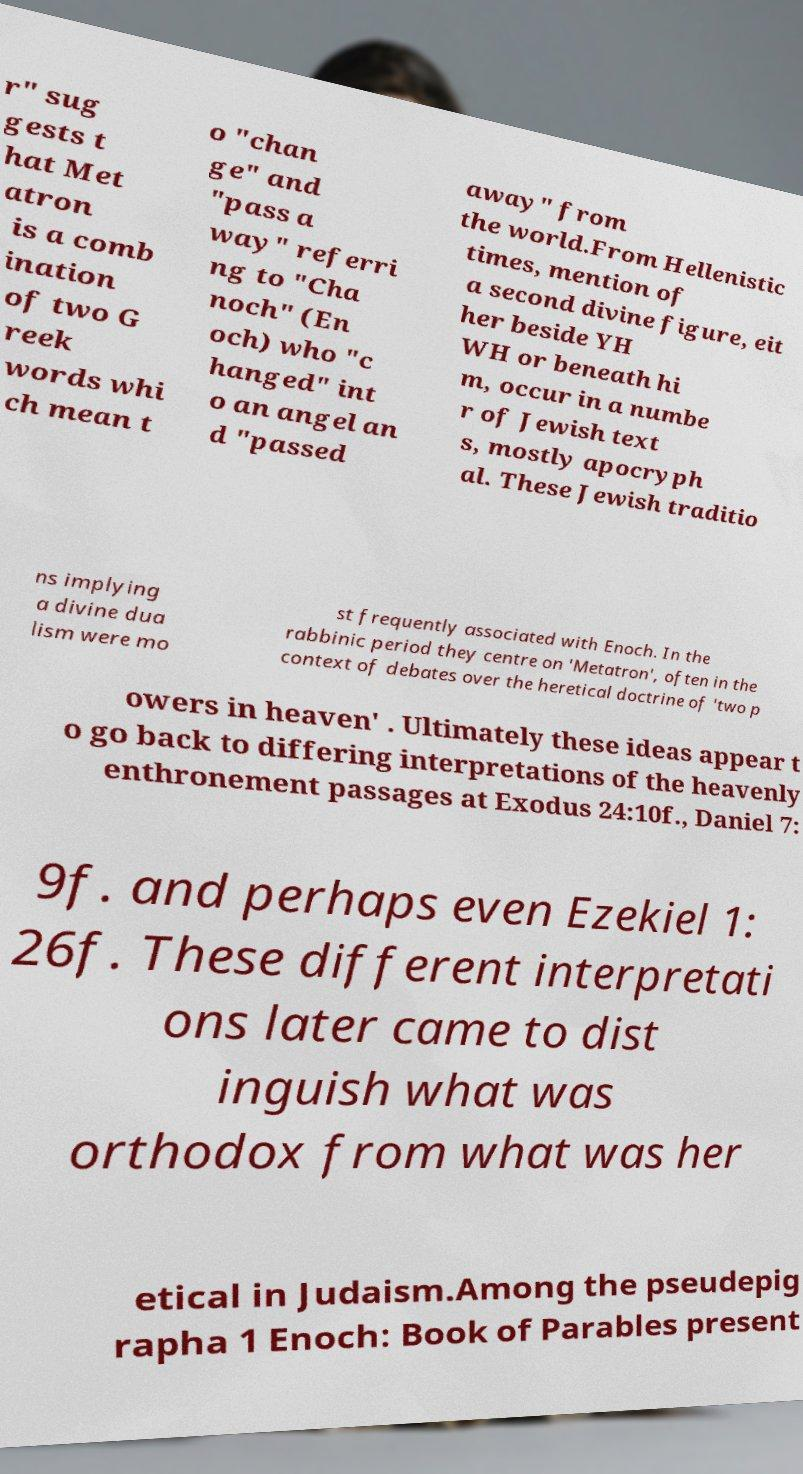Can you accurately transcribe the text from the provided image for me? r" sug gests t hat Met atron is a comb ination of two G reek words whi ch mean t o "chan ge" and "pass a way" referri ng to "Cha noch" (En och) who "c hanged" int o an angel an d "passed away" from the world.From Hellenistic times, mention of a second divine figure, eit her beside YH WH or beneath hi m, occur in a numbe r of Jewish text s, mostly apocryph al. These Jewish traditio ns implying a divine dua lism were mo st frequently associated with Enoch. In the rabbinic period they centre on 'Metatron', often in the context of debates over the heretical doctrine of 'two p owers in heaven' . Ultimately these ideas appear t o go back to differing interpretations of the heavenly enthronement passages at Exodus 24:10f., Daniel 7: 9f. and perhaps even Ezekiel 1: 26f. These different interpretati ons later came to dist inguish what was orthodox from what was her etical in Judaism.Among the pseudepig rapha 1 Enoch: Book of Parables present 